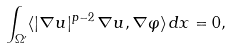Convert formula to latex. <formula><loc_0><loc_0><loc_500><loc_500>\int _ { \Omega ^ { \prime } } \langle | \nabla u | ^ { p - 2 } \, \nabla u , \nabla \varphi \rangle \, d x = 0 ,</formula> 